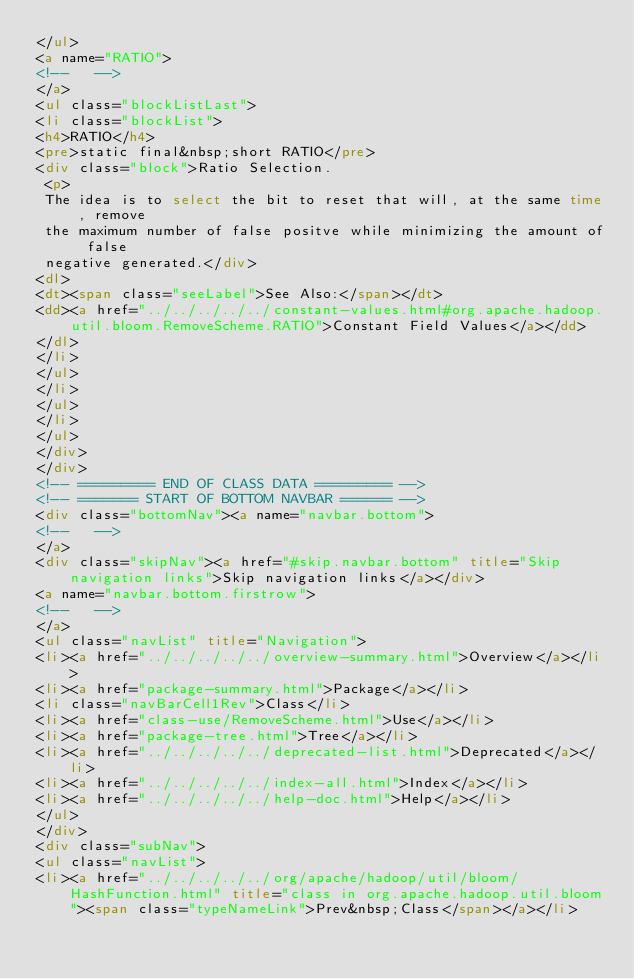Convert code to text. <code><loc_0><loc_0><loc_500><loc_500><_HTML_></ul>
<a name="RATIO">
<!--   -->
</a>
<ul class="blockListLast">
<li class="blockList">
<h4>RATIO</h4>
<pre>static final&nbsp;short RATIO</pre>
<div class="block">Ratio Selection.
 <p>
 The idea is to select the bit to reset that will, at the same time, remove
 the maximum number of false positve while minimizing the amount of false
 negative generated.</div>
<dl>
<dt><span class="seeLabel">See Also:</span></dt>
<dd><a href="../../../../../constant-values.html#org.apache.hadoop.util.bloom.RemoveScheme.RATIO">Constant Field Values</a></dd>
</dl>
</li>
</ul>
</li>
</ul>
</li>
</ul>
</div>
</div>
<!-- ========= END OF CLASS DATA ========= -->
<!-- ======= START OF BOTTOM NAVBAR ====== -->
<div class="bottomNav"><a name="navbar.bottom">
<!--   -->
</a>
<div class="skipNav"><a href="#skip.navbar.bottom" title="Skip navigation links">Skip navigation links</a></div>
<a name="navbar.bottom.firstrow">
<!--   -->
</a>
<ul class="navList" title="Navigation">
<li><a href="../../../../../overview-summary.html">Overview</a></li>
<li><a href="package-summary.html">Package</a></li>
<li class="navBarCell1Rev">Class</li>
<li><a href="class-use/RemoveScheme.html">Use</a></li>
<li><a href="package-tree.html">Tree</a></li>
<li><a href="../../../../../deprecated-list.html">Deprecated</a></li>
<li><a href="../../../../../index-all.html">Index</a></li>
<li><a href="../../../../../help-doc.html">Help</a></li>
</ul>
</div>
<div class="subNav">
<ul class="navList">
<li><a href="../../../../../org/apache/hadoop/util/bloom/HashFunction.html" title="class in org.apache.hadoop.util.bloom"><span class="typeNameLink">Prev&nbsp;Class</span></a></li></code> 